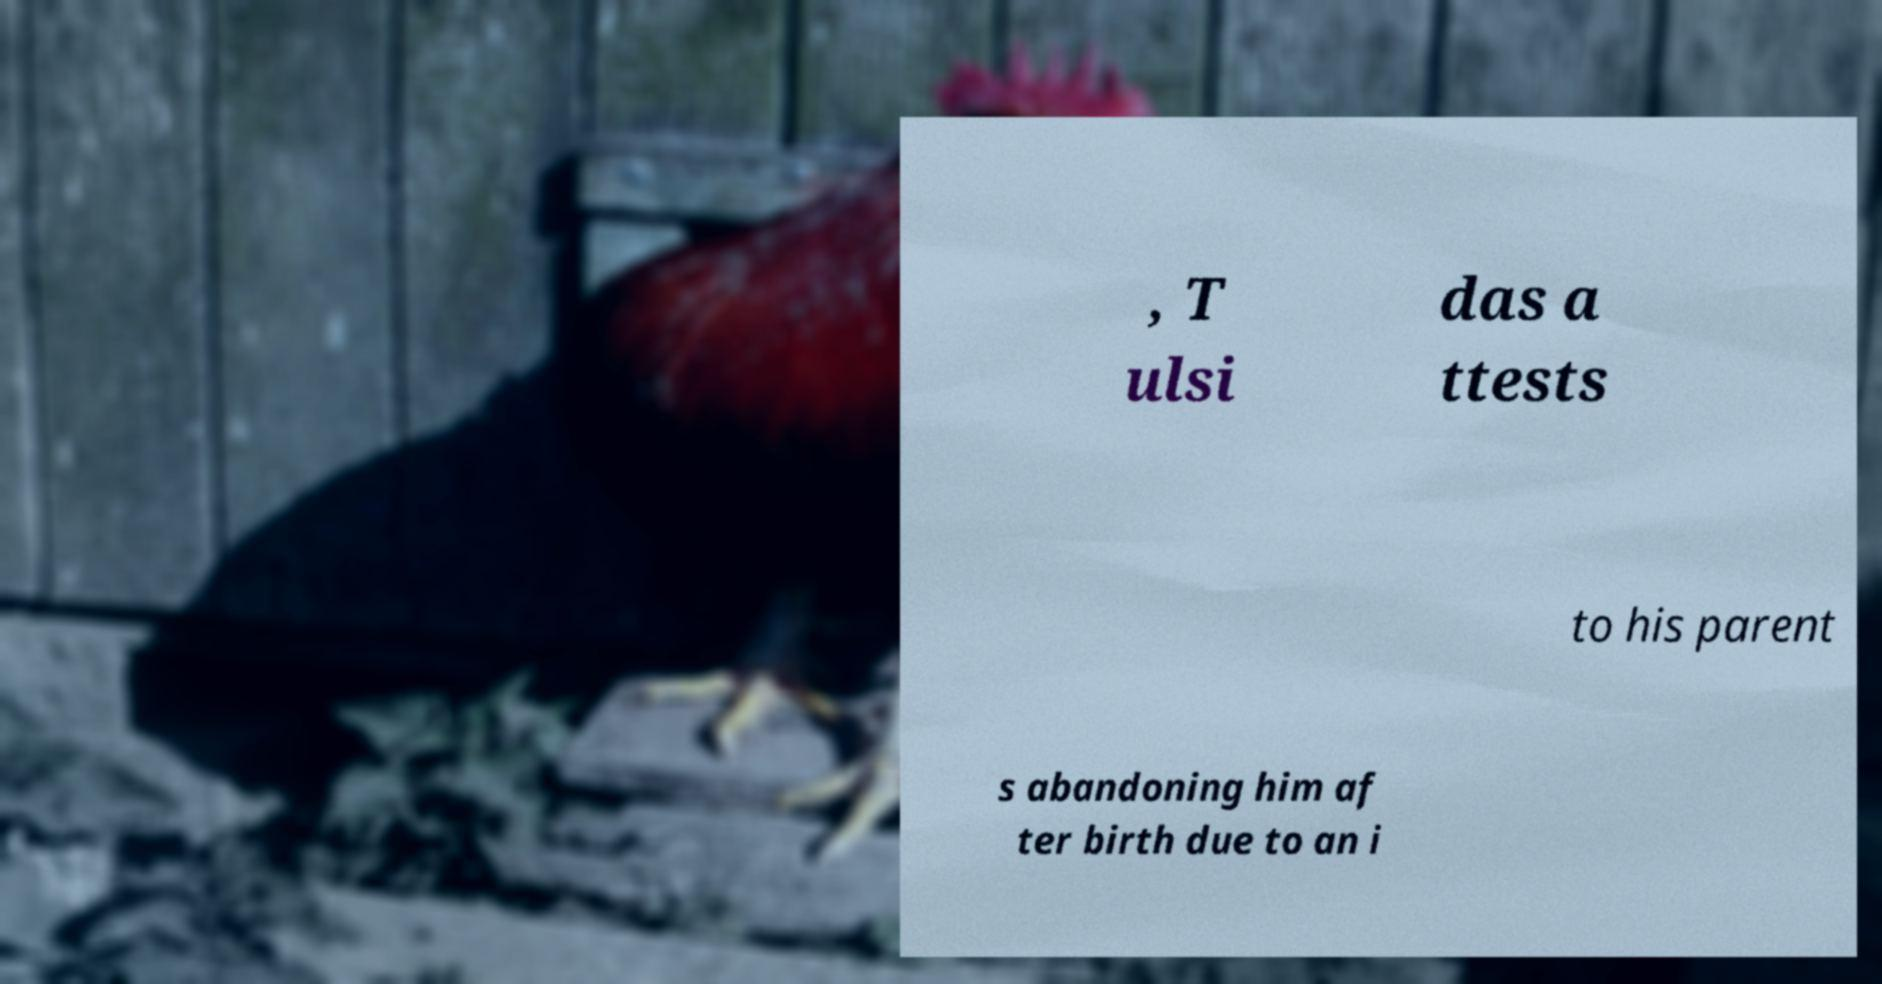Could you assist in decoding the text presented in this image and type it out clearly? , T ulsi das a ttests to his parent s abandoning him af ter birth due to an i 